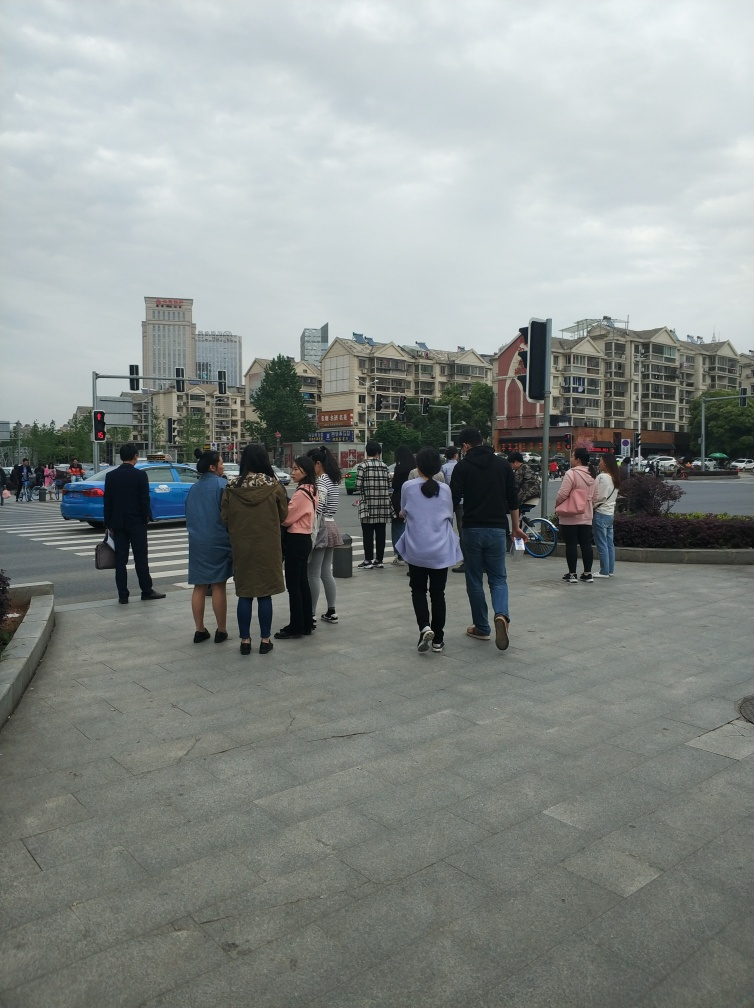Can you describe the weather conditions in the photo? The sky is overcast with no visible shadows, suggesting that the weather is cloudy, which results in a soft, diffuse light over the urban landscape. 